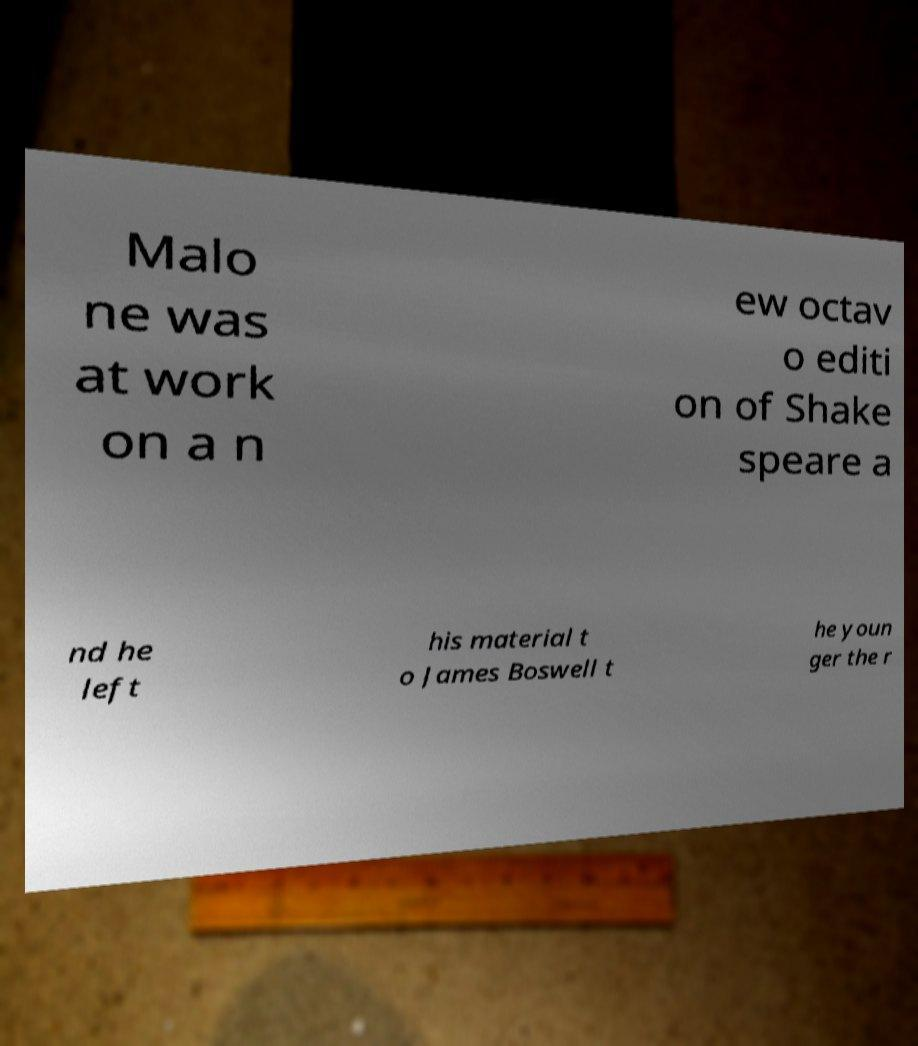Can you read and provide the text displayed in the image?This photo seems to have some interesting text. Can you extract and type it out for me? Malo ne was at work on a n ew octav o editi on of Shake speare a nd he left his material t o James Boswell t he youn ger the r 